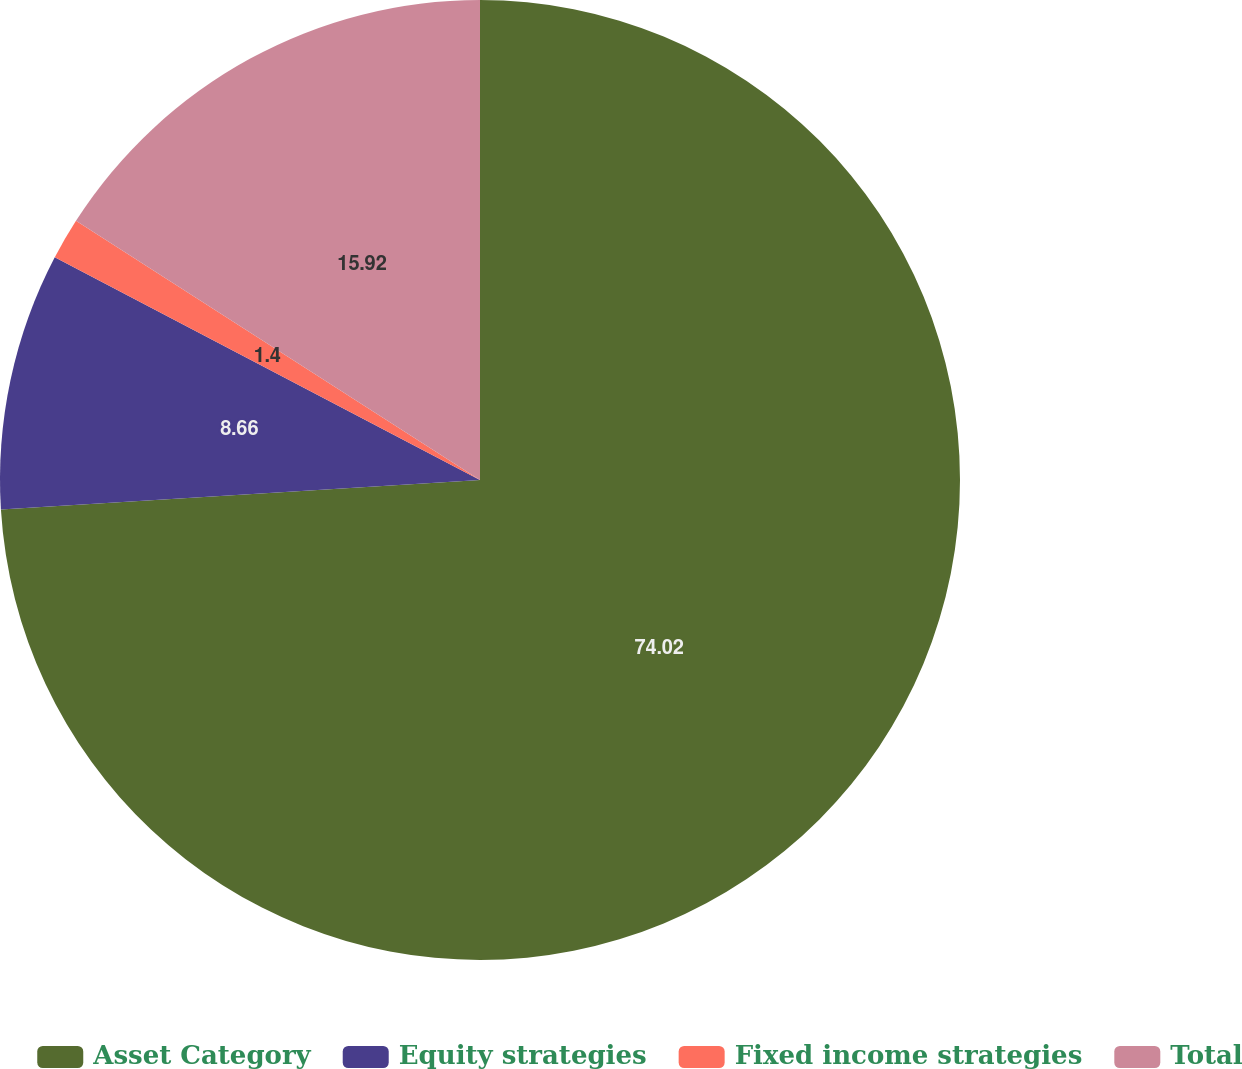Convert chart to OTSL. <chart><loc_0><loc_0><loc_500><loc_500><pie_chart><fcel>Asset Category<fcel>Equity strategies<fcel>Fixed income strategies<fcel>Total<nl><fcel>74.01%<fcel>8.66%<fcel>1.4%<fcel>15.92%<nl></chart> 